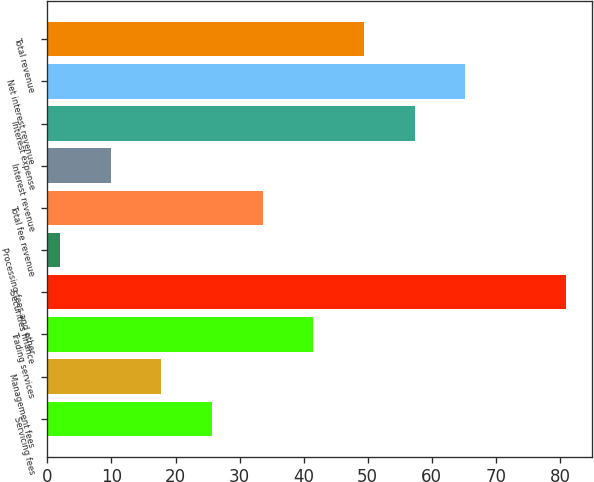<chart> <loc_0><loc_0><loc_500><loc_500><bar_chart><fcel>Servicing fees<fcel>Management fees<fcel>Trading services<fcel>Securities finance<fcel>Processing fees and other<fcel>Total fee revenue<fcel>Interest revenue<fcel>Interest expense<fcel>Net interest revenue<fcel>Total revenue<nl><fcel>25.7<fcel>17.8<fcel>41.5<fcel>81<fcel>2<fcel>33.6<fcel>9.9<fcel>57.3<fcel>65.2<fcel>49.4<nl></chart> 